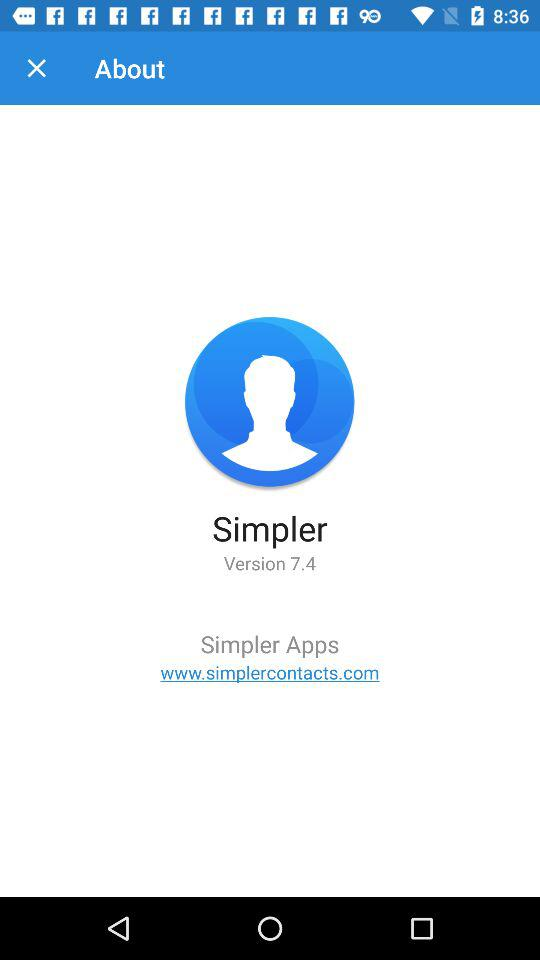What is the name of the application? The name of the application is "Simpler". 